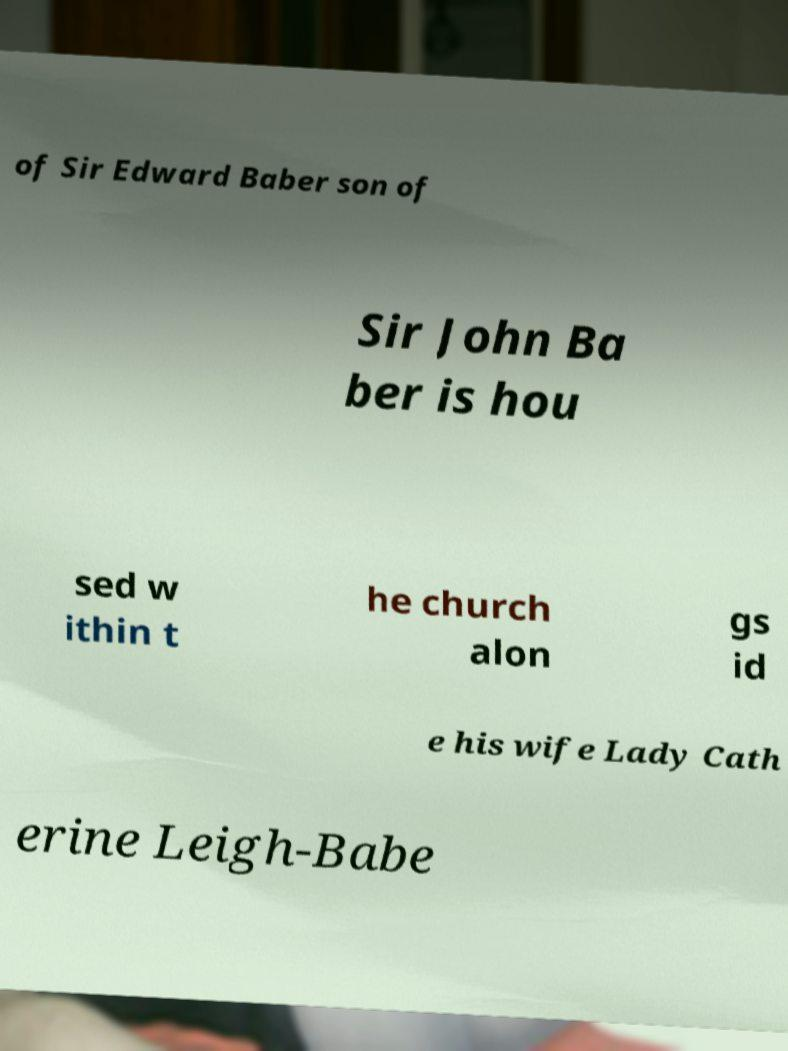For documentation purposes, I need the text within this image transcribed. Could you provide that? of Sir Edward Baber son of Sir John Ba ber is hou sed w ithin t he church alon gs id e his wife Lady Cath erine Leigh-Babe 